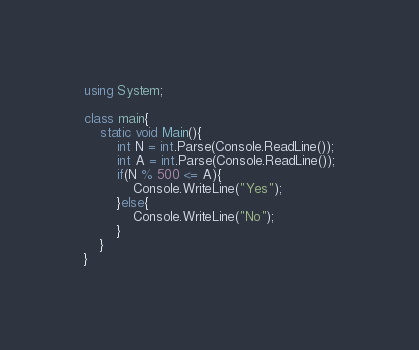Convert code to text. <code><loc_0><loc_0><loc_500><loc_500><_C#_>using System;

class main{
	static void Main(){
		int N = int.Parse(Console.ReadLine());
		int A = int.Parse(Console.ReadLine());
		if(N % 500 <= A){
			Console.WriteLine("Yes");
		}else{
			Console.WriteLine("No");
		}
	}
}
</code> 